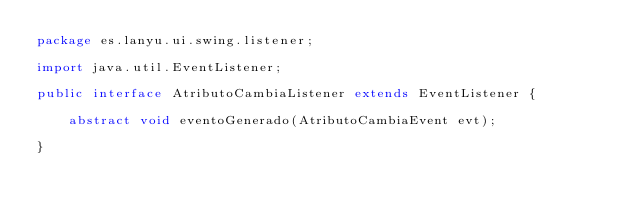<code> <loc_0><loc_0><loc_500><loc_500><_Java_>package es.lanyu.ui.swing.listener;

import java.util.EventListener;

public interface AtributoCambiaListener extends EventListener {
	
	abstract void eventoGenerado(AtributoCambiaEvent evt);
	
}
</code> 